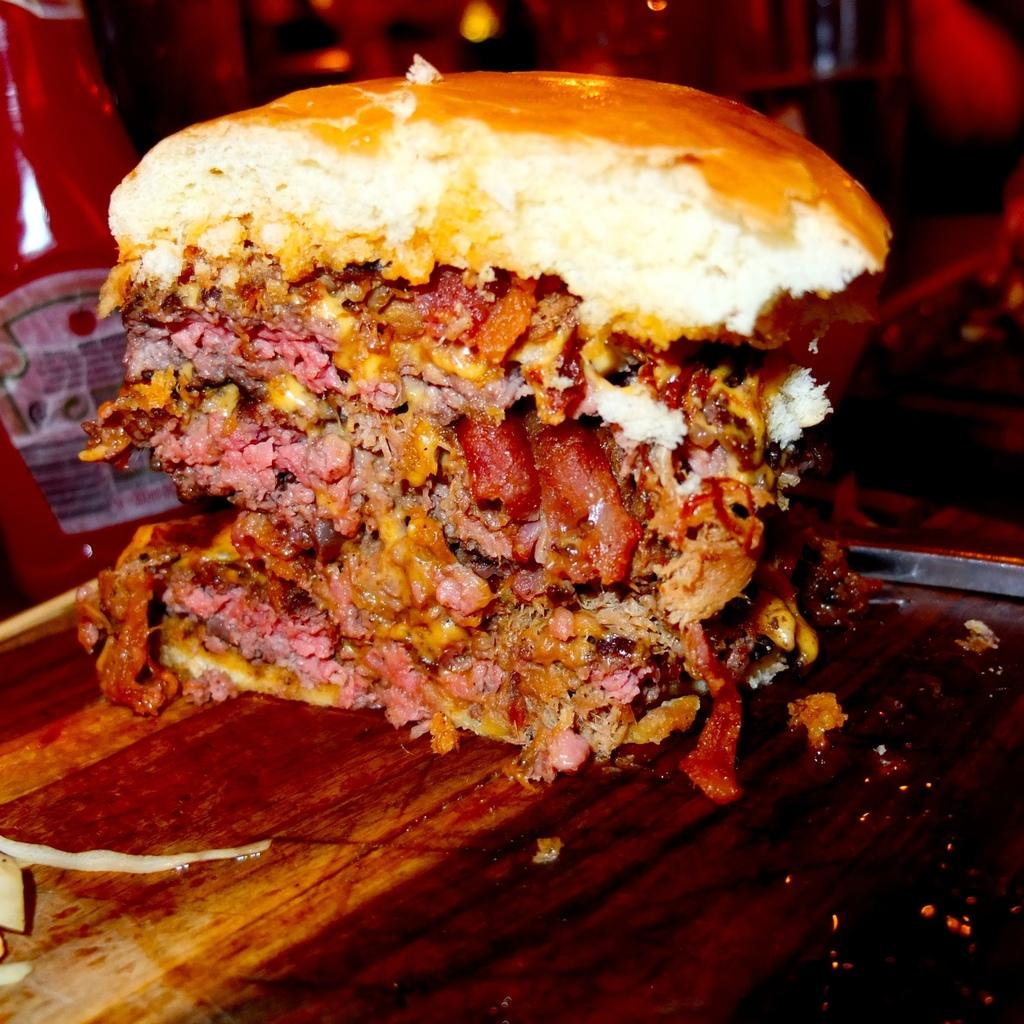What is the main subject in the middle of the image? There is food in the middle of the image. What is located beside the food? There is a bottle beside the food. Where are the food and the bottle placed? Both the food and the bottle are on a table. What type of vest is being worn by the food in the image? There is no vest present in the image, as the main subject is food and not a person or an animal. 